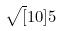<formula> <loc_0><loc_0><loc_500><loc_500>\sqrt { [ } 1 0 ] { 5 }</formula> 